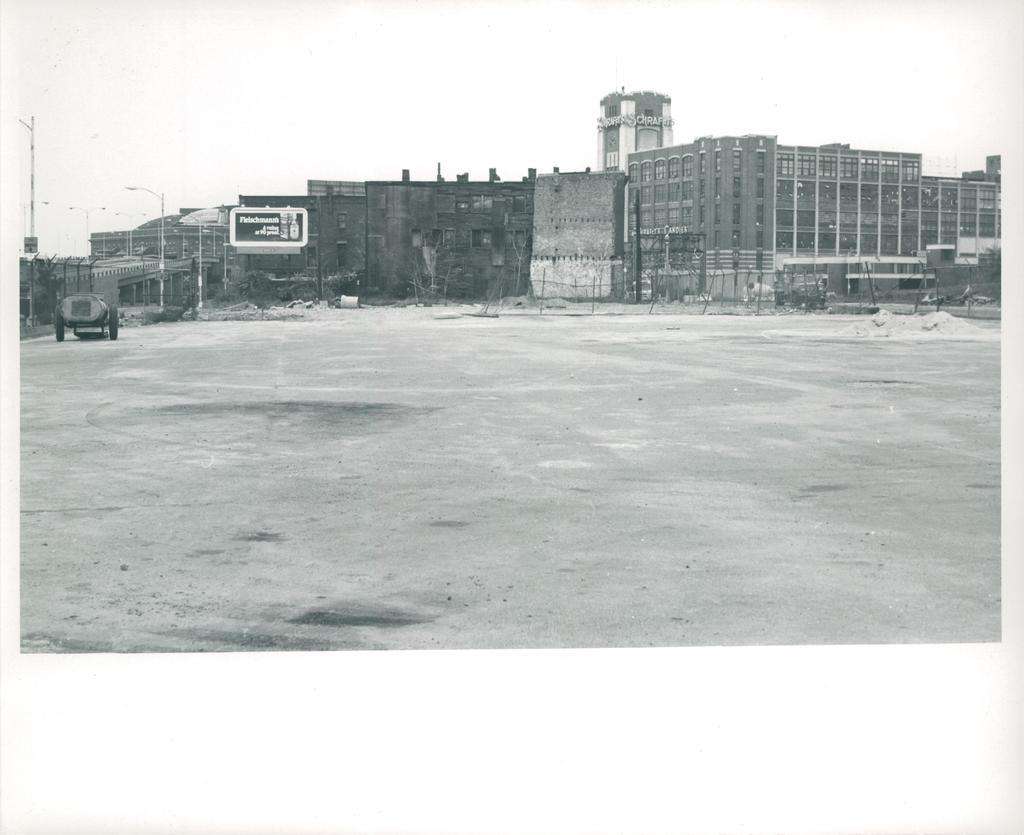What is the main feature of the image? There is a road in the image. What else can be seen in the image besides the road? There are buildings, a hoarding, and street light poles in the image. What is the condition of the sky in the image? The sky is clear in the image. What is the color scheme of the image? The image is in black and white color. Can you see the reason for the traffic jam in the image? There is no traffic jam mentioned in the image, so it's not possible to determine the reason for one. Is there a crown visible on any of the buildings in the image? There is no crown present on any of the buildings in the image. 